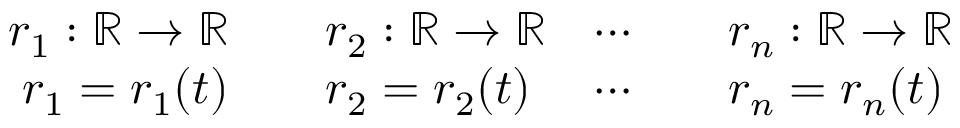<formula> <loc_0><loc_0><loc_500><loc_500>\begin{array} { r l r l } { r _ { 1 } \colon \mathbb { R } \rightarrow \mathbb { R } } & \quad r _ { 2 } \colon \mathbb { R } \rightarrow \mathbb { R } } & { \cdots } & \quad r _ { n } \colon \mathbb { R } \rightarrow \mathbb { R } } \\ { r _ { 1 } = r _ { 1 } ( t ) } & \quad r _ { 2 } = r _ { 2 } ( t ) } & { \cdots } & \quad r _ { n } = r _ { n } ( t ) } \end{array}</formula> 